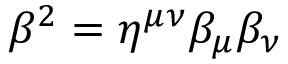Convert formula to latex. <formula><loc_0><loc_0><loc_500><loc_500>\beta ^ { 2 } = \eta ^ { \mu \nu } \beta _ { \mu } \beta _ { \nu }</formula> 